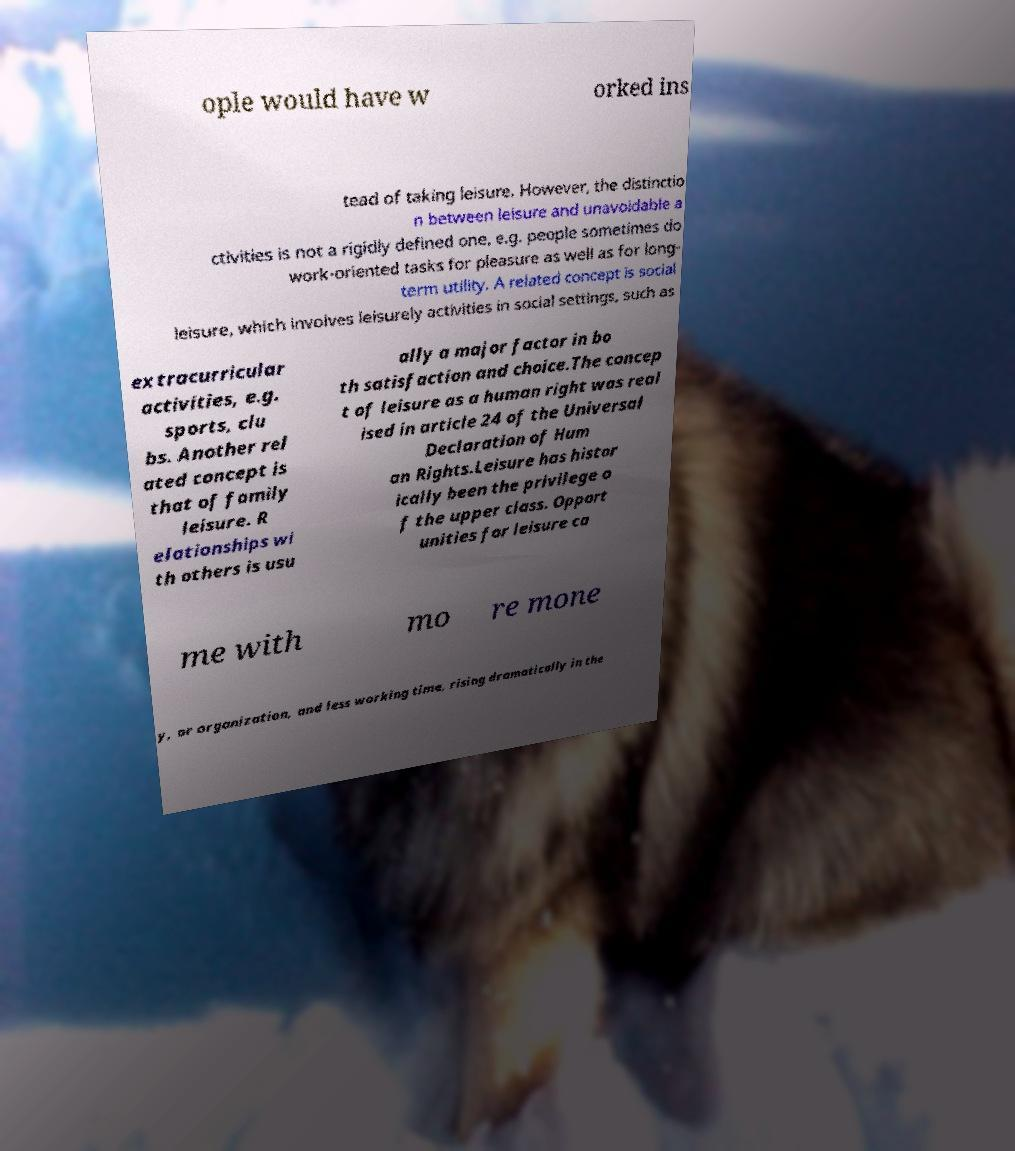There's text embedded in this image that I need extracted. Can you transcribe it verbatim? ople would have w orked ins tead of taking leisure. However, the distinctio n between leisure and unavoidable a ctivities is not a rigidly defined one, e.g. people sometimes do work-oriented tasks for pleasure as well as for long- term utility. A related concept is social leisure, which involves leisurely activities in social settings, such as extracurricular activities, e.g. sports, clu bs. Another rel ated concept is that of family leisure. R elationships wi th others is usu ally a major factor in bo th satisfaction and choice.The concep t of leisure as a human right was real ised in article 24 of the Universal Declaration of Hum an Rights.Leisure has histor ically been the privilege o f the upper class. Opport unities for leisure ca me with mo re mone y, or organization, and less working time, rising dramatically in the 